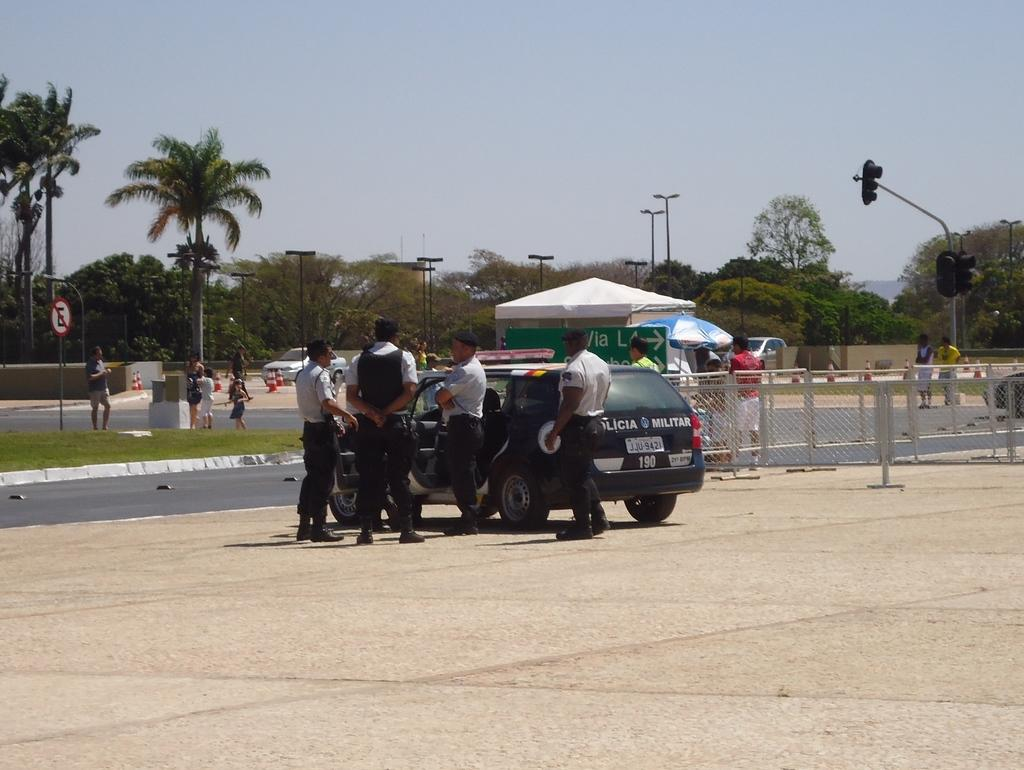What types of living beings can be seen in the image? There are people in the image. What else can be seen in the image besides people? There are vehicles, trees, light poles, traffic signals, sign boards, tents, umbrellas, and fencing in the image. What is the color of the sky in the image? The sky is blue and white in color. Can you tell me where the cabbage is located in the image? There is no cabbage present in the image. What direction should we take to reach the destination mentioned on the sign board in the image? The image does not provide enough information to determine the direction we should take. 